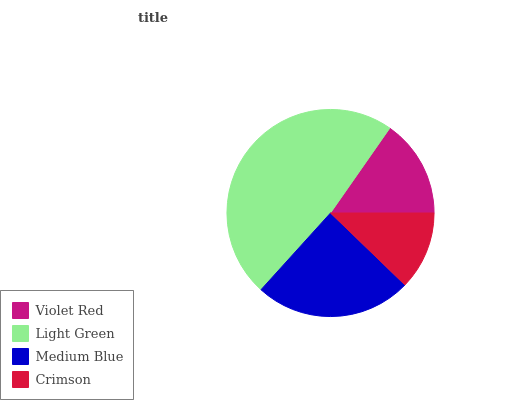Is Crimson the minimum?
Answer yes or no. Yes. Is Light Green the maximum?
Answer yes or no. Yes. Is Medium Blue the minimum?
Answer yes or no. No. Is Medium Blue the maximum?
Answer yes or no. No. Is Light Green greater than Medium Blue?
Answer yes or no. Yes. Is Medium Blue less than Light Green?
Answer yes or no. Yes. Is Medium Blue greater than Light Green?
Answer yes or no. No. Is Light Green less than Medium Blue?
Answer yes or no. No. Is Medium Blue the high median?
Answer yes or no. Yes. Is Violet Red the low median?
Answer yes or no. Yes. Is Light Green the high median?
Answer yes or no. No. Is Crimson the low median?
Answer yes or no. No. 